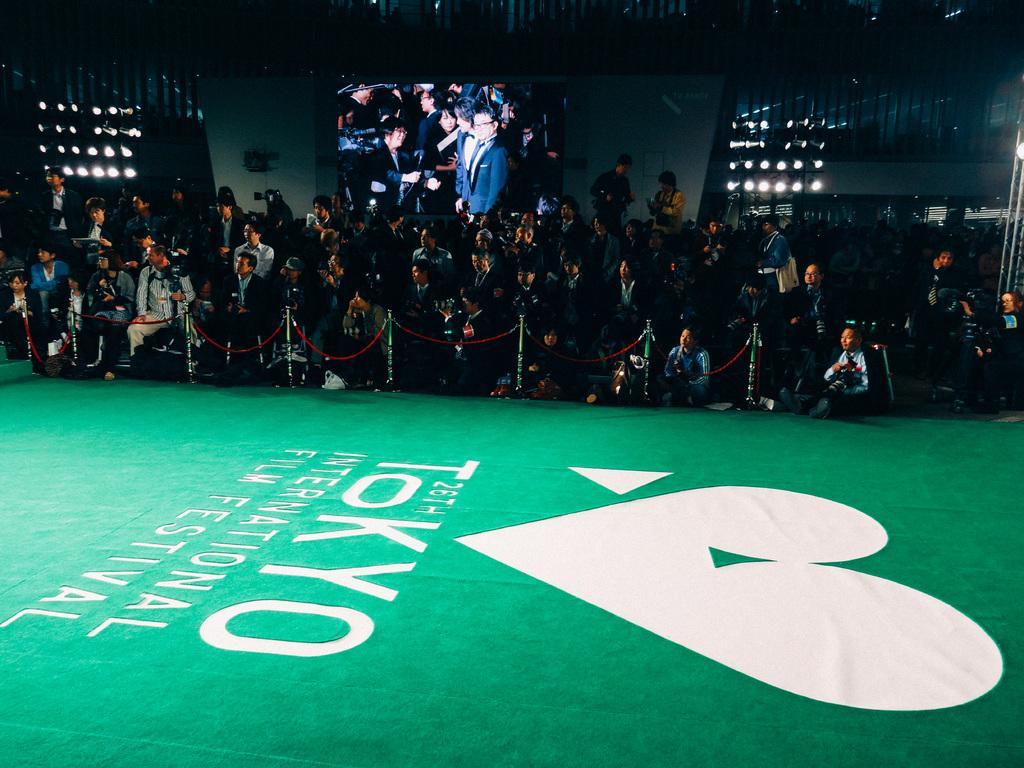In one or two sentences, can you explain what this image depicts? In this picture there is a stage at the bottom side of the image and there is a boundary in the center of the image and there are many people those who are standing in front of the boundary as audience, there is a projector screen in the center of the image and there are spot lights on the right and left side of the image. 